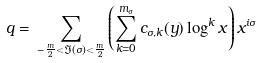Convert formula to latex. <formula><loc_0><loc_0><loc_500><loc_500>q = \, \sum _ { - \frac { m } { 2 } < \Im ( \sigma ) < \frac { m } { 2 } } \left ( \sum _ { k = 0 } ^ { m _ { \sigma } } c _ { \sigma , k } ( y ) \log ^ { k } x \right ) x ^ { i \sigma }</formula> 